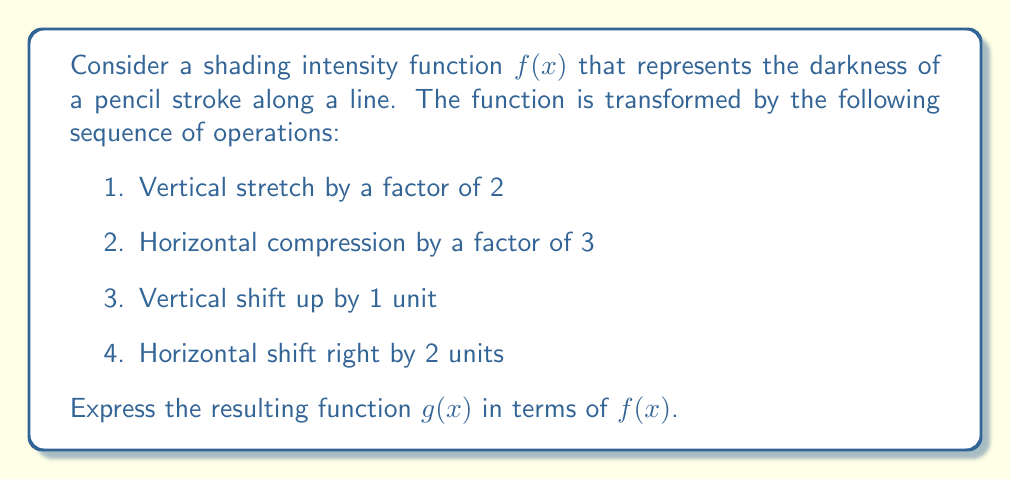Can you solve this math problem? Let's apply the transformations step by step:

1. Vertical stretch by a factor of 2:
   $f_1(x) = 2f(x)$

2. Horizontal compression by a factor of 3:
   $f_2(x) = 2f(3x)$

3. Vertical shift up by 1 unit:
   $f_3(x) = 2f(3x) + 1$

4. Horizontal shift right by 2 units:
   To shift right, we replace $x$ with $(x-2)$:
   $g(x) = 2f(3(x-2)) + 1$

Therefore, the final transformed function $g(x)$ is:
$$g(x) = 2f(3x-6) + 1$$

This expression represents the composition of all four transformations applied to the original shading intensity function $f(x)$.
Answer: $g(x) = 2f(3x-6) + 1$ 